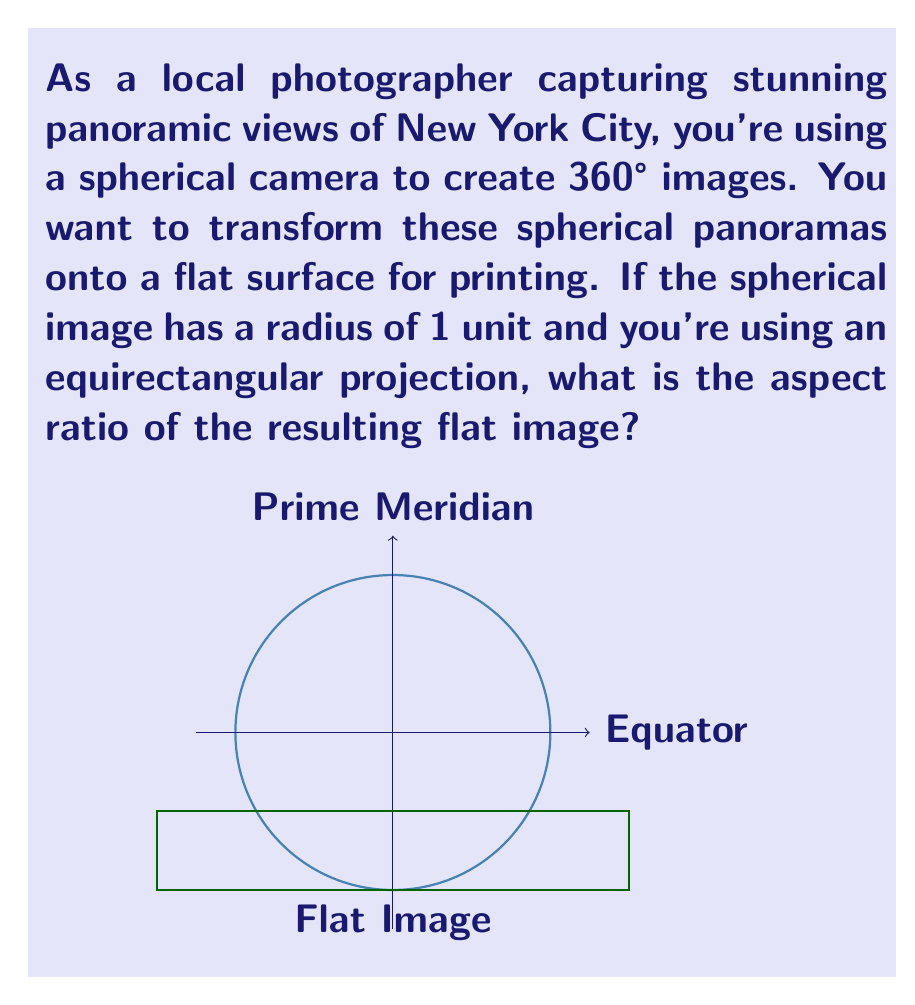Could you help me with this problem? Let's approach this step-by-step:

1) In an equirectangular projection, the longitude is mapped linearly to the horizontal axis, and the latitude is mapped linearly to the vertical axis.

2) The circumference of the sphere at the equator becomes the width of the flat image:
   Width = $2\pi r$ where $r$ is the radius of the sphere.

3) The height of the flat image corresponds to the distance from the North Pole to the South Pole along a meridian:
   Height = $\pi r$

4) Given that the radius $r = 1$:
   Width = $2\pi$
   Height = $\pi$

5) The aspect ratio is defined as Width : Height
   Aspect Ratio = $2\pi : \pi$ = $2 : 1$

6) This can be simplified to 2:1
Answer: 2:1 